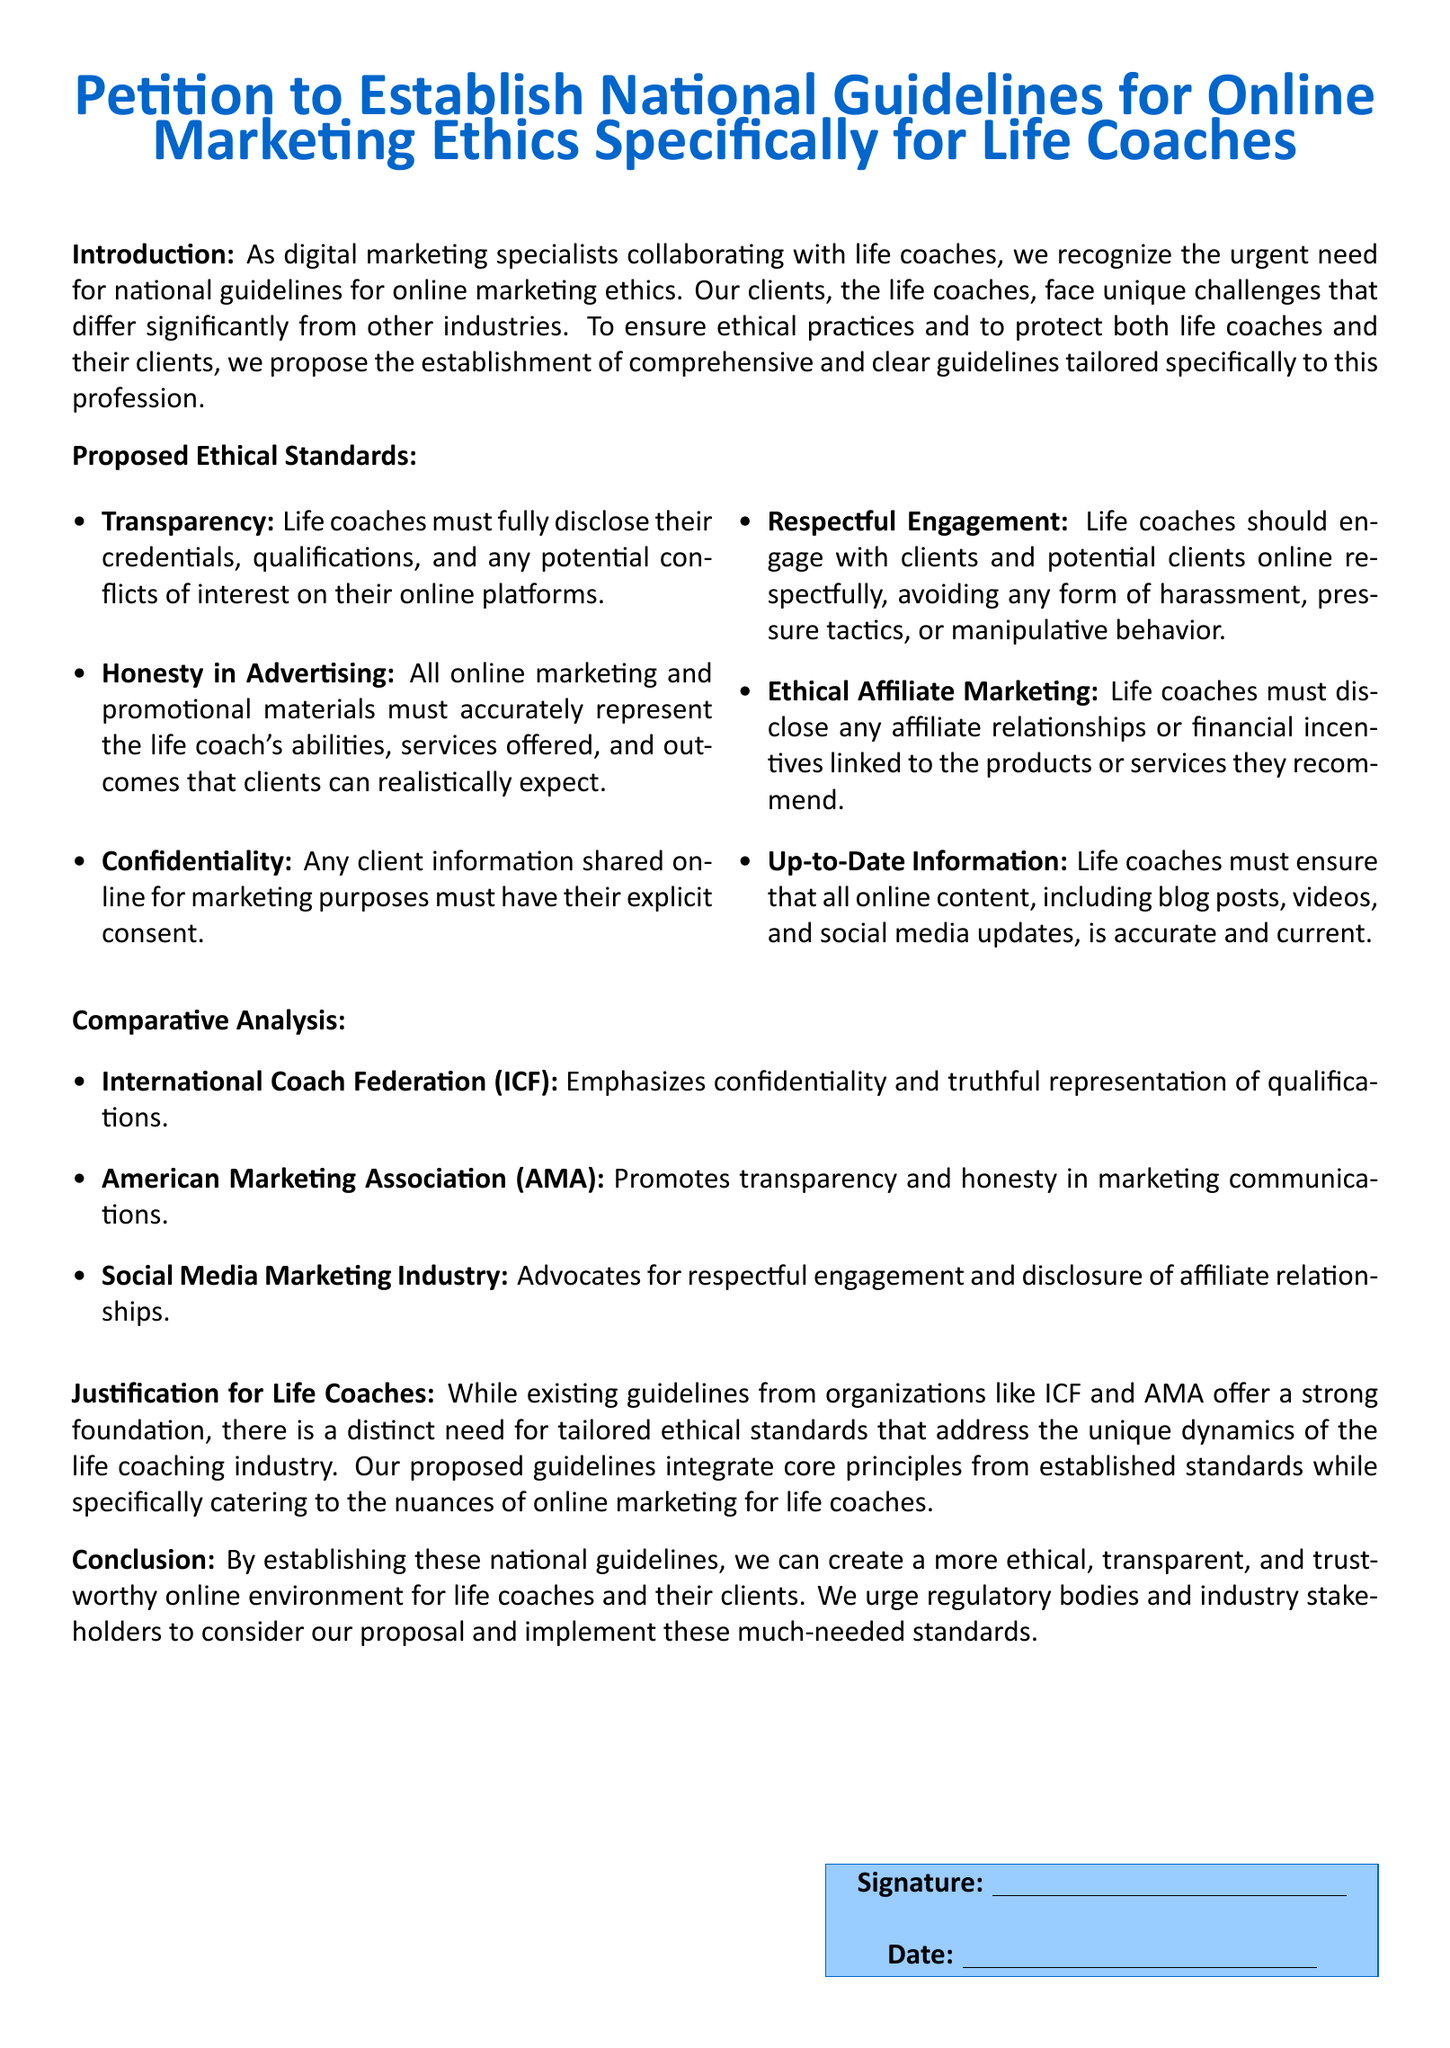What is the title of the petition? The title of the petition is clearly stated at the top of the document and outlines its purpose.
Answer: Petition to Establish National Guidelines for Online Marketing Ethics Specifically for Life Coaches What is the primary purpose of the proposed ethical standards? The purpose is elaborated in the introduction, addressing the need for ethical practices specifically for life coaches.
Answer: Ensure ethical practices What standard requires life coaches to disclose their qualifications? The specific standard that addresses disclosure of credentials is listed in the proposed ethical standards.
Answer: Transparency Which organization emphasizes confidentiality? The comparative analysis mentions organizations and their focus areas, including confidentiality.
Answer: International Coach Federation (ICF) How many proposed ethical standards are listed? The document contains a list of ethical standards, which can be counted to determine the total number.
Answer: Six 